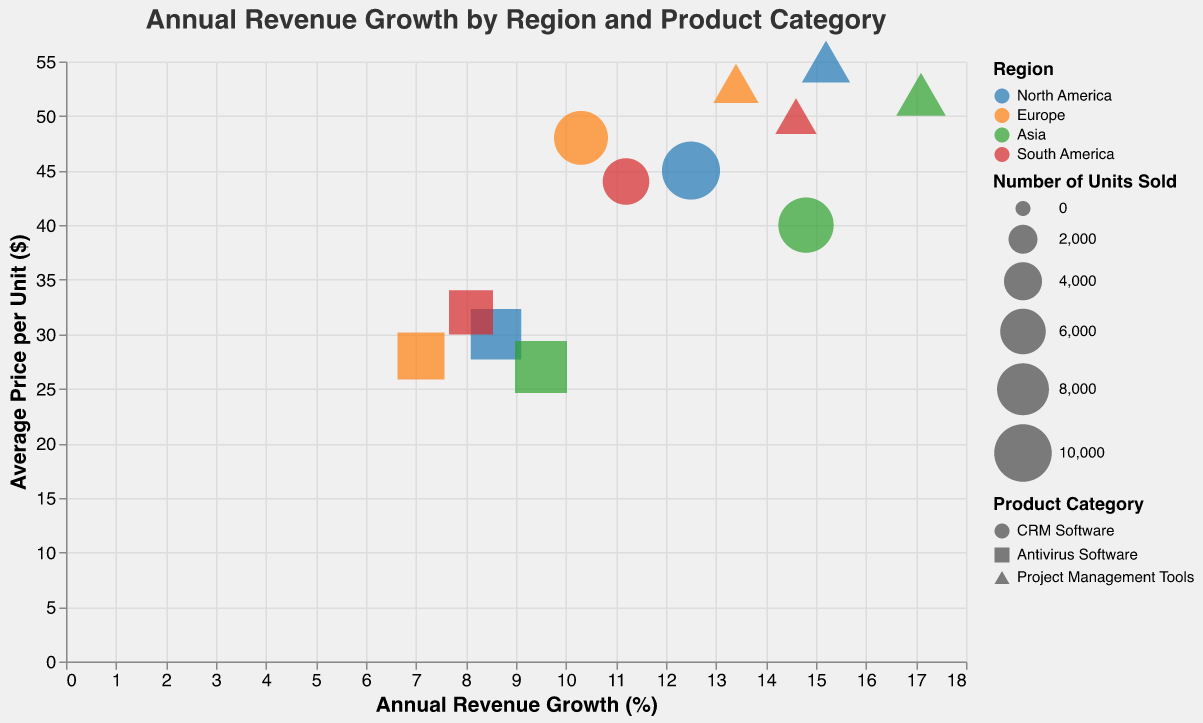What's the title of the figure? The title is displayed at the top of the figure. By reading it, we can identify the title.
Answer: Annual Revenue Growth by Region and Product Category How many data points are represented in the bubble chart? Each row in the provided data corresponds to a data point in the bubble chart. Counting the rows, we have a total of 12 data points.
Answer: 12 Which region has the highest average annual revenue growth for CRM Software? We need to look at the data points with the "CRM Software" product category and compare their annual revenue growth percentages across regions. Asia has the highest growth at 14.8%.
Answer: Asia What is the average price per unit for Project Management Tools in Europe? Find the data point for "Project Management Tools" in Europe and check the average price per unit, which is indicated in the axis values.
Answer: $53.00 Compare the number of units sold for Antivirus Software in North America and South America. Which region sold more units? Look at the data points for "Antivirus Software" in both North America and South America, then compare the "Number of Units Sold" for these data points; North America has 7500, and South America has 5600.
Answer: North America Which product category has the highest annual revenue growth in South America? Check the data points for South America and compare the annual revenue growth percentages among the product categories. "Project Management Tools" has the highest growth at 14.6%.
Answer: Project Management Tools What is the difference in the average price per unit for CRM Software between North America and Asia? Find the data points for "CRM Software" in North America and Asia, then calculate the difference in their average prices per unit: $45 (North America) - $40 (Asia) = $5.00.
Answer: $5.00 Which region has the least number of units sold for CRM Software? Compare the "Number of Units Sold" for the "CRM Software" category across all regions. South America has the least, with 6300 units sold.
Answer: South America Identify the region and product category with the highest annual revenue growth. Look through all data points and find the data point with the maximum value in the "Annual Revenue Growth" field, which is "Project Management Tools" in Asia with 17.1%.
Answer: Project Management Tools in Asia What is the average annual revenue growth for Antivirus Software across all regions? Calculate the average of the annual revenue growth percentages for "Antivirus Software" across all regions: (8.6 + 7.1 + 9.5 + 8.1) / 4 = 8.33%.
Answer: 8.33% 